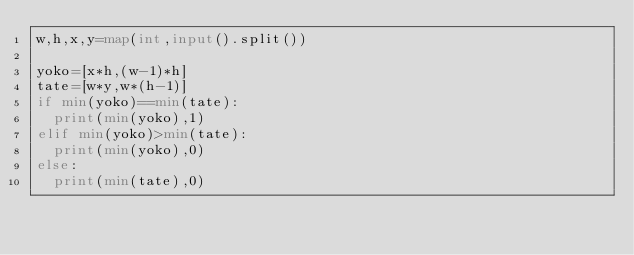<code> <loc_0><loc_0><loc_500><loc_500><_Python_>w,h,x,y=map(int,input().split())

yoko=[x*h,(w-1)*h]
tate=[w*y,w*(h-1)]
if min(yoko)==min(tate):
  print(min(yoko),1)
elif min(yoko)>min(tate):
  print(min(yoko),0)
else:
  print(min(tate),0)</code> 